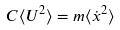<formula> <loc_0><loc_0><loc_500><loc_500>C \langle U ^ { 2 } \rangle = m \langle \dot { x } ^ { 2 } \rangle</formula> 